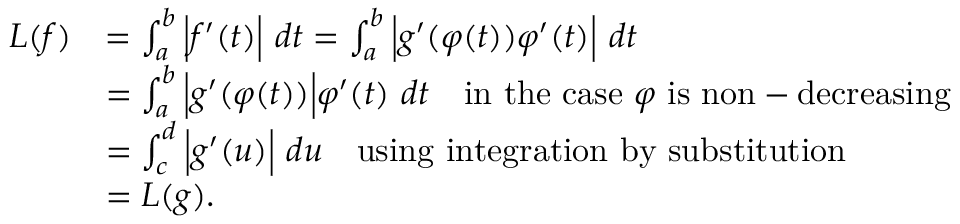Convert formula to latex. <formula><loc_0><loc_0><loc_500><loc_500>{ \begin{array} { r l } { L ( f ) } & { = \int _ { a } ^ { b } { \left | } f ^ { \prime } ( t ) { \right | } \ d t = \int _ { a } ^ { b } { \left | } g ^ { \prime } ( \varphi ( t ) ) \varphi ^ { \prime } ( t ) { \right | } \ d t } \\ & { = \int _ { a } ^ { b } { \left | } g ^ { \prime } ( \varphi ( t ) ) { \right | } \varphi ^ { \prime } ( t ) \ d t \quad i n t h e c a s e \varphi { i s n o n - d e c r e a \sin g } } \\ & { = \int _ { c } ^ { d } { \left | } g ^ { \prime } ( u ) { \right | } \ d u \quad u \sin g i n t e g r a t i o n b y s u b s t i t u t i o n } \\ & { = L ( g ) . } \end{array} }</formula> 